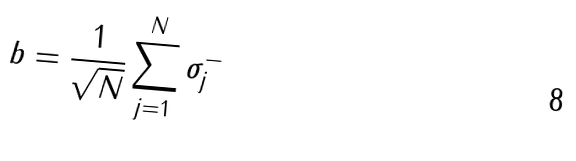Convert formula to latex. <formula><loc_0><loc_0><loc_500><loc_500>b = \frac { 1 } { \sqrt { N } } \sum _ { j = 1 } ^ { N } \sigma _ { j } ^ { - }</formula> 